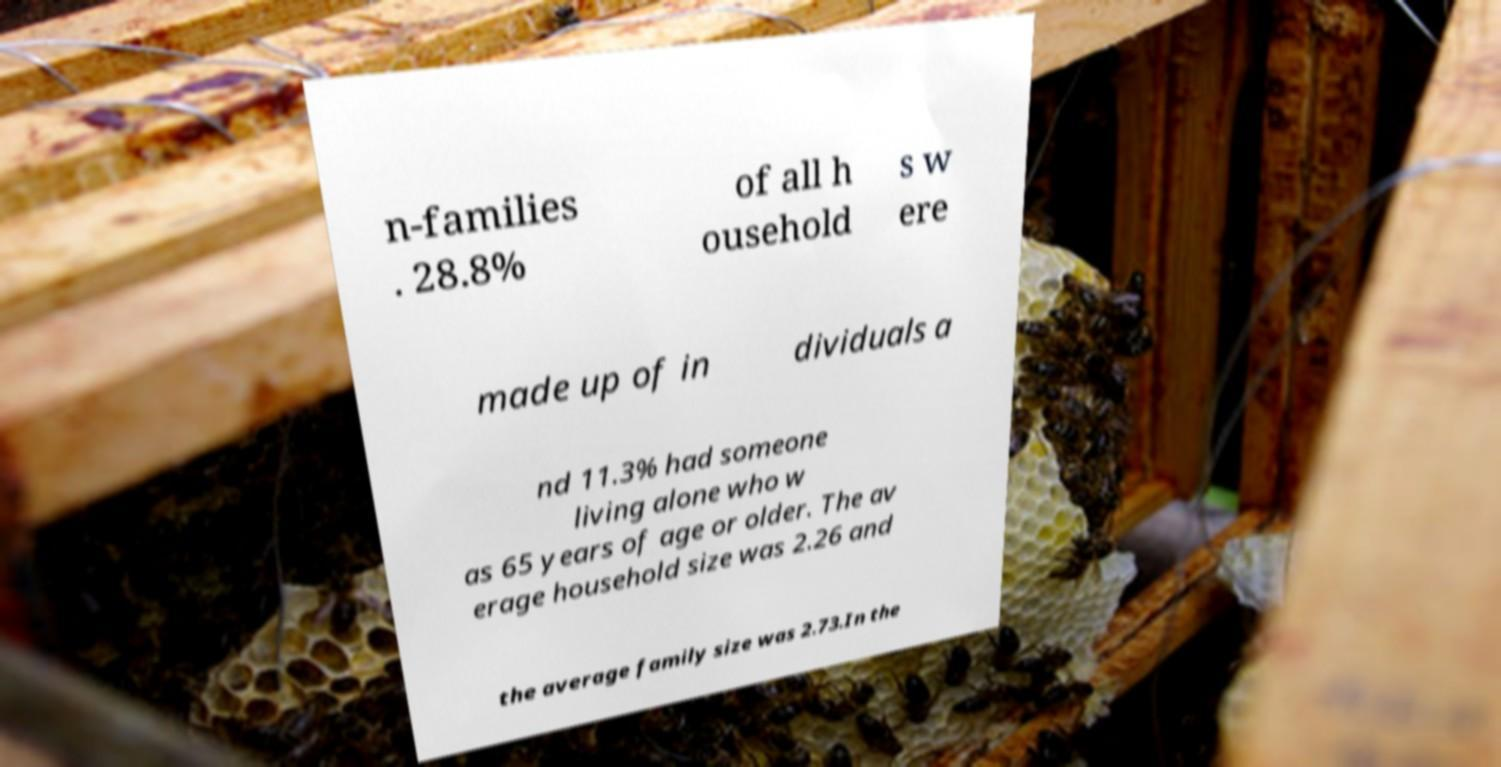There's text embedded in this image that I need extracted. Can you transcribe it verbatim? n-families . 28.8% of all h ousehold s w ere made up of in dividuals a nd 11.3% had someone living alone who w as 65 years of age or older. The av erage household size was 2.26 and the average family size was 2.73.In the 